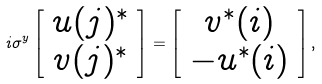Convert formula to latex. <formula><loc_0><loc_0><loc_500><loc_500>i \sigma ^ { y } \left [ \begin{array} { c } u ( j ) ^ { * } \\ v ( j ) ^ { * } \end{array} \right ] = \left [ \begin{array} { c } v ^ { * } ( i ) \\ - u ^ { * } ( i ) \end{array} \right ] ,</formula> 